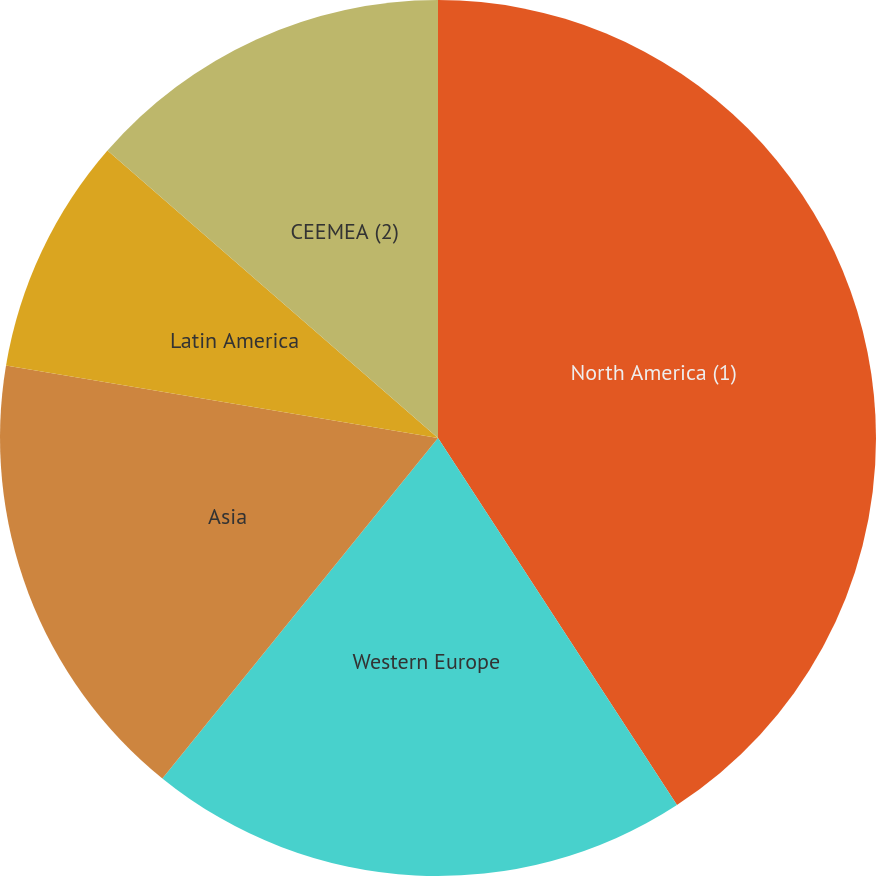Convert chart to OTSL. <chart><loc_0><loc_0><loc_500><loc_500><pie_chart><fcel>North America (1)<fcel>Western Europe<fcel>Asia<fcel>Latin America<fcel>CEEMEA (2)<nl><fcel>40.82%<fcel>20.02%<fcel>16.81%<fcel>8.75%<fcel>13.61%<nl></chart> 